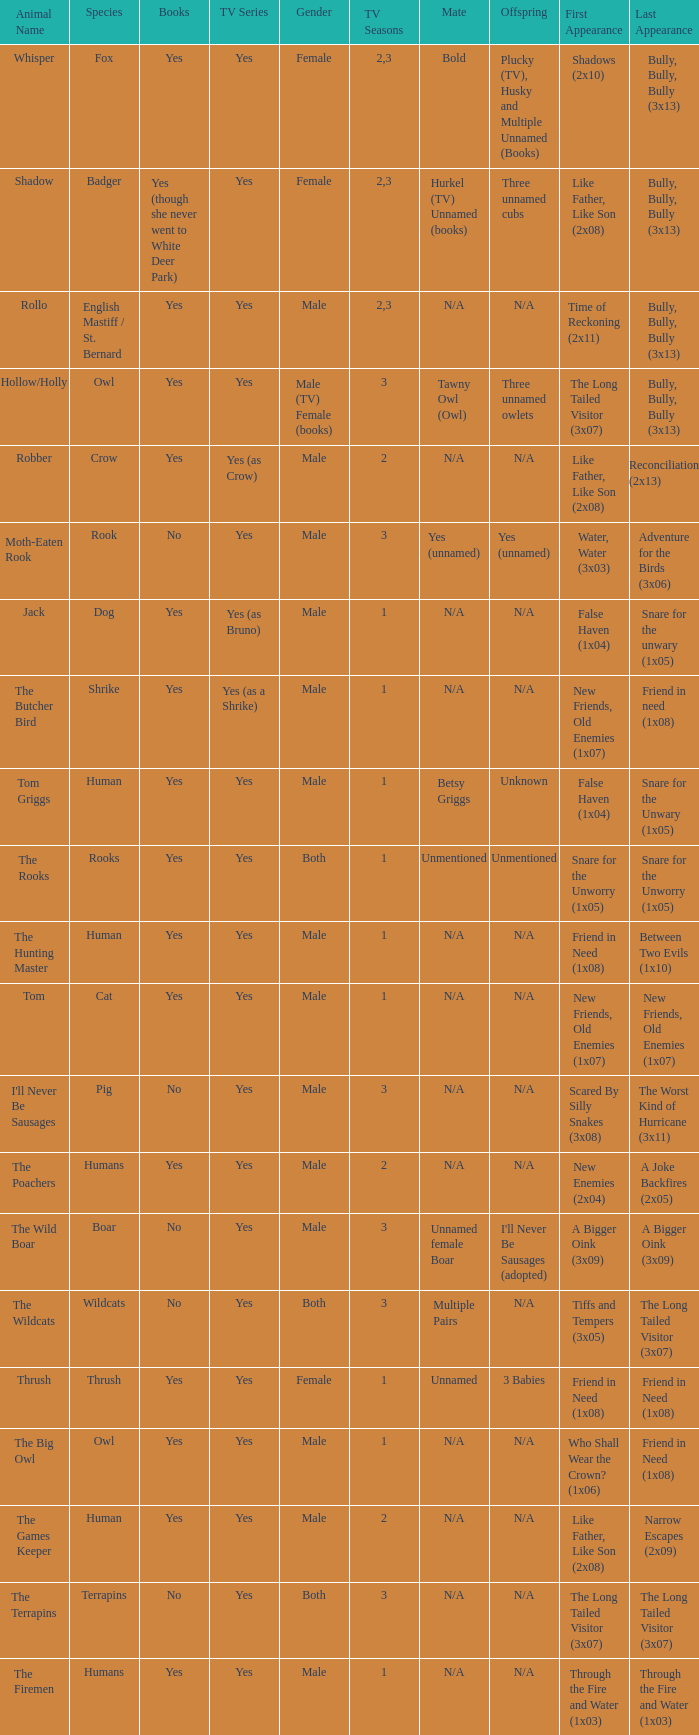Parse the table in full. {'header': ['Animal Name', 'Species', 'Books', 'TV Series', 'Gender', 'TV Seasons', 'Mate', 'Offspring', 'First Appearance', 'Last Appearance'], 'rows': [['Whisper', 'Fox', 'Yes', 'Yes', 'Female', '2,3', 'Bold', 'Plucky (TV), Husky and Multiple Unnamed (Books)', 'Shadows (2x10)', 'Bully, Bully, Bully (3x13)'], ['Shadow', 'Badger', 'Yes (though she never went to White Deer Park)', 'Yes', 'Female', '2,3', 'Hurkel (TV) Unnamed (books)', 'Three unnamed cubs', 'Like Father, Like Son (2x08)', 'Bully, Bully, Bully (3x13)'], ['Rollo', 'English Mastiff / St. Bernard', 'Yes', 'Yes', 'Male', '2,3', 'N/A', 'N/A', 'Time of Reckoning (2x11)', 'Bully, Bully, Bully (3x13)'], ['Hollow/Holly', 'Owl', 'Yes', 'Yes', 'Male (TV) Female (books)', '3', 'Tawny Owl (Owl)', 'Three unnamed owlets', 'The Long Tailed Visitor (3x07)', 'Bully, Bully, Bully (3x13)'], ['Robber', 'Crow', 'Yes', 'Yes (as Crow)', 'Male', '2', 'N/A', 'N/A', 'Like Father, Like Son (2x08)', 'Reconciliation (2x13)'], ['Moth-Eaten Rook', 'Rook', 'No', 'Yes', 'Male', '3', 'Yes (unnamed)', 'Yes (unnamed)', 'Water, Water (3x03)', 'Adventure for the Birds (3x06)'], ['Jack', 'Dog', 'Yes', 'Yes (as Bruno)', 'Male', '1', 'N/A', 'N/A', 'False Haven (1x04)', 'Snare for the unwary (1x05)'], ['The Butcher Bird', 'Shrike', 'Yes', 'Yes (as a Shrike)', 'Male', '1', 'N/A', 'N/A', 'New Friends, Old Enemies (1x07)', 'Friend in need (1x08)'], ['Tom Griggs', 'Human', 'Yes', 'Yes', 'Male', '1', 'Betsy Griggs', 'Unknown', 'False Haven (1x04)', 'Snare for the Unwary (1x05)'], ['The Rooks', 'Rooks', 'Yes', 'Yes', 'Both', '1', 'Unmentioned', 'Unmentioned', 'Snare for the Unworry (1x05)', 'Snare for the Unworry (1x05)'], ['The Hunting Master', 'Human', 'Yes', 'Yes', 'Male', '1', 'N/A', 'N/A', 'Friend in Need (1x08)', 'Between Two Evils (1x10)'], ['Tom', 'Cat', 'Yes', 'Yes', 'Male', '1', 'N/A', 'N/A', 'New Friends, Old Enemies (1x07)', 'New Friends, Old Enemies (1x07)'], ["I'll Never Be Sausages", 'Pig', 'No', 'Yes', 'Male', '3', 'N/A', 'N/A', 'Scared By Silly Snakes (3x08)', 'The Worst Kind of Hurricane (3x11)'], ['The Poachers', 'Humans', 'Yes', 'Yes', 'Male', '2', 'N/A', 'N/A', 'New Enemies (2x04)', 'A Joke Backfires (2x05)'], ['The Wild Boar', 'Boar', 'No', 'Yes', 'Male', '3', 'Unnamed female Boar', "I'll Never Be Sausages (adopted)", 'A Bigger Oink (3x09)', 'A Bigger Oink (3x09)'], ['The Wildcats', 'Wildcats', 'No', 'Yes', 'Both', '3', 'Multiple Pairs', 'N/A', 'Tiffs and Tempers (3x05)', 'The Long Tailed Visitor (3x07)'], ['Thrush', 'Thrush', 'Yes', 'Yes', 'Female', '1', 'Unnamed', '3 Babies', 'Friend in Need (1x08)', 'Friend in Need (1x08)'], ['The Big Owl', 'Owl', 'Yes', 'Yes', 'Male', '1', 'N/A', 'N/A', 'Who Shall Wear the Crown? (1x06)', 'Friend in Need (1x08)'], ['The Games Keeper', 'Human', 'Yes', 'Yes', 'Male', '2', 'N/A', 'N/A', 'Like Father, Like Son (2x08)', 'Narrow Escapes (2x09)'], ['The Terrapins', 'Terrapins', 'No', 'Yes', 'Both', '3', 'N/A', 'N/A', 'The Long Tailed Visitor (3x07)', 'The Long Tailed Visitor (3x07)'], ['The Firemen', 'Humans', 'Yes', 'Yes', 'Male', '1', 'N/A', 'N/A', 'Through the Fire and Water (1x03)', 'Through the Fire and Water (1x03)']]} In a tv series with human species and a 'yes' element, which season has the least number of episodes? 1.0. 